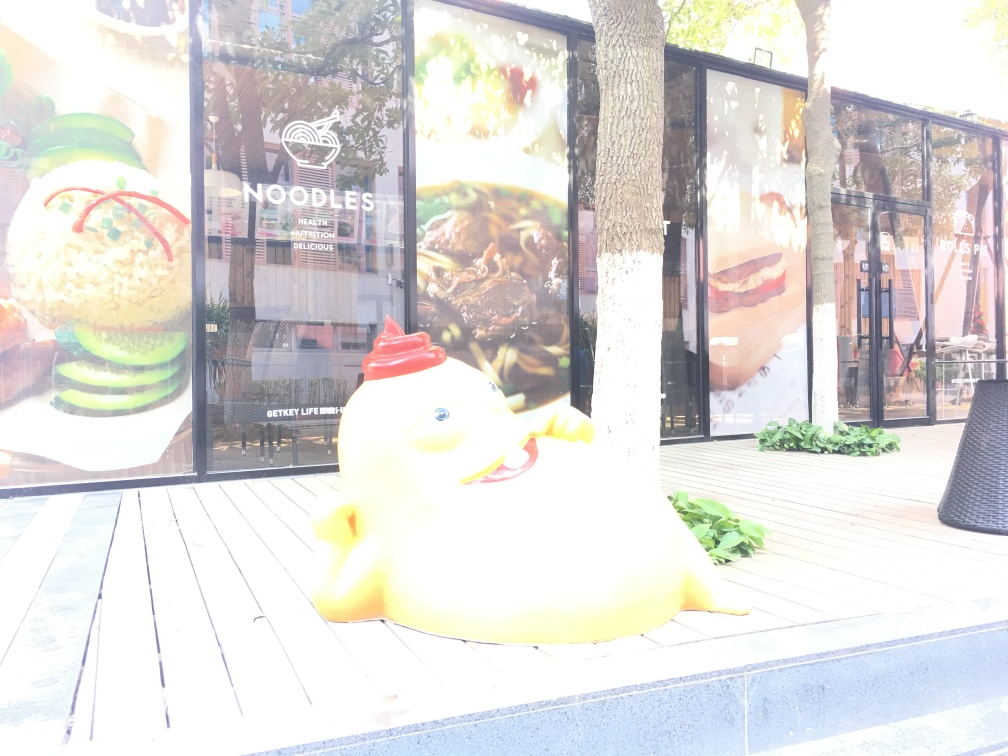Does this image tell a story or convey a message? The image may suggest a narrative of urban creativity or playful marketing strategies. The whimsical nature of the main subject, with its bright colors and cartoonish features, could be a way for businesses to attract customers, especially families with children or those who appreciate lighthearted art in public spaces. What can you infer about the time of day when this photo was taken? Considering the strong light and shadows cast on the deck and the brightness behind the glass windows, it appears that the photo was taken during the day when the sun was bright, possibly around midday to early afternoon, which has resulted in the overexposure issue. What improvements could be made to capture a better quality image in this setting? To improve the photo quality, adjusting the camera's exposure settings would be essential, to avoid overexposure from the bright sunlight. Using a lower ISO setting, faster shutter speed, or smaller aperture could help capture more details in the brightly lit areas. Additionally, waiting for a time of day with softer light, such as early morning or late afternoon, or using a polarizing filter could also enhance the photo quality and clarity. 